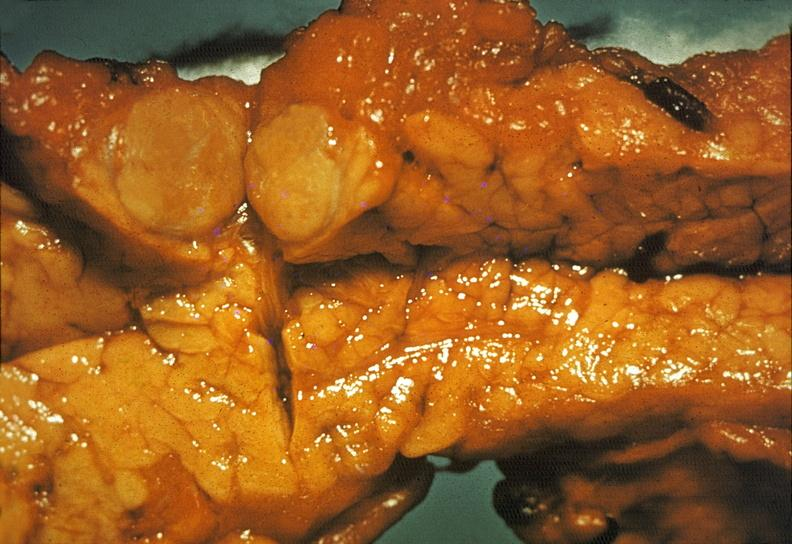s pancreas present?
Answer the question using a single word or phrase. Yes 